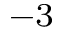<formula> <loc_0><loc_0><loc_500><loc_500>^ { - 3 }</formula> 